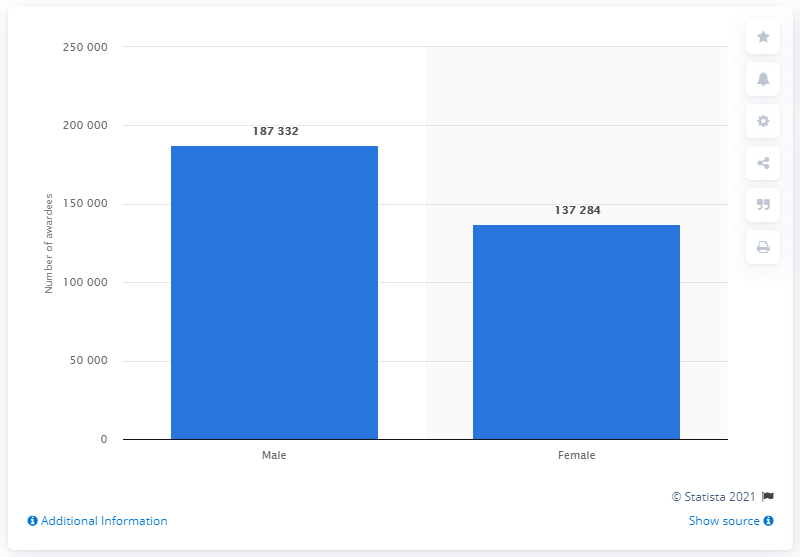Highlight a few significant elements in this photo. In 2019, a total of 187,332 male students were awarded their undergraduate degree in Bihar. 